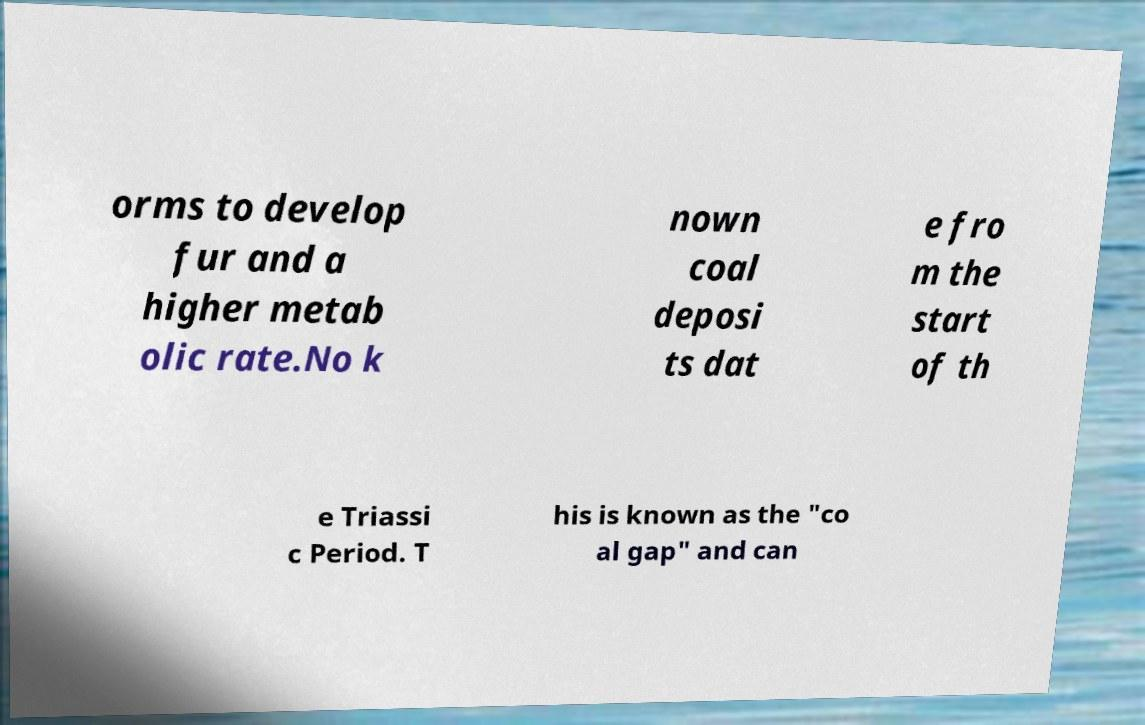Please read and relay the text visible in this image. What does it say? orms to develop fur and a higher metab olic rate.No k nown coal deposi ts dat e fro m the start of th e Triassi c Period. T his is known as the "co al gap" and can 